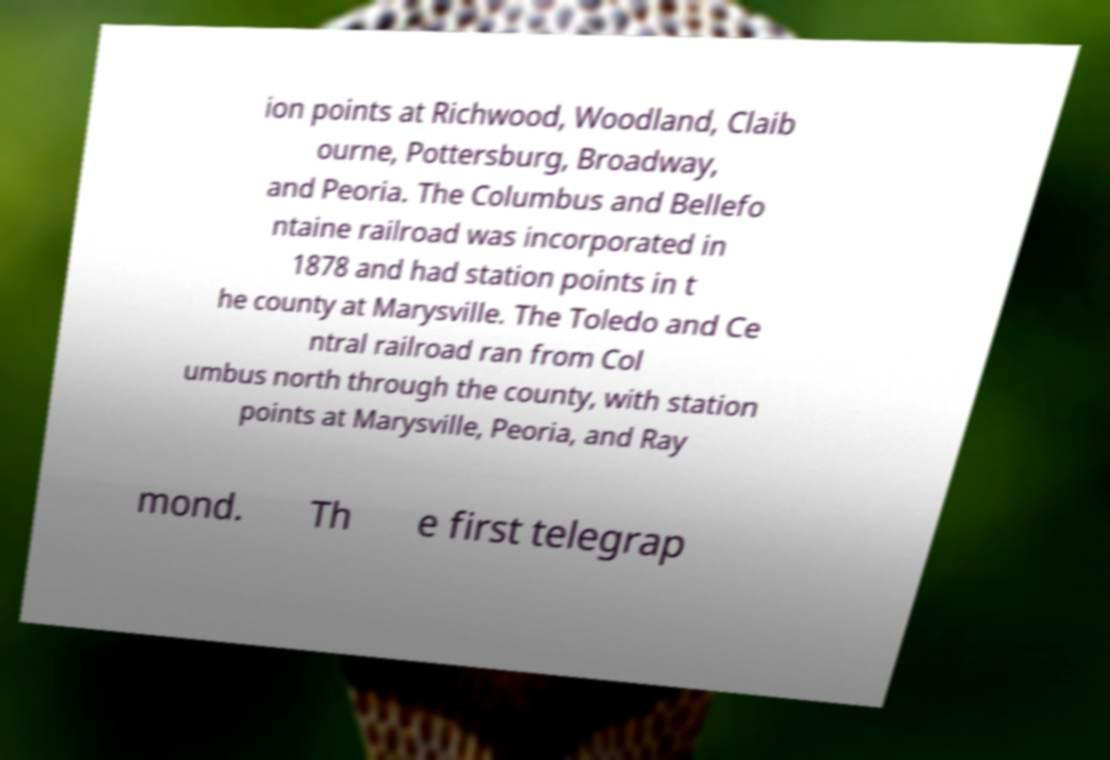There's text embedded in this image that I need extracted. Can you transcribe it verbatim? ion points at Richwood, Woodland, Claib ourne, Pottersburg, Broadway, and Peoria. The Columbus and Bellefo ntaine railroad was incorporated in 1878 and had station points in t he county at Marysville. The Toledo and Ce ntral railroad ran from Col umbus north through the county, with station points at Marysville, Peoria, and Ray mond. Th e first telegrap 